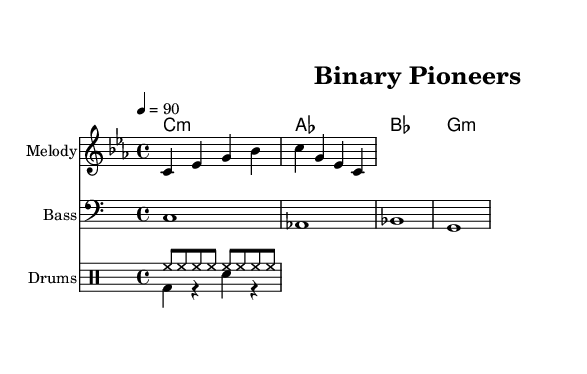What is the key signature of this music? The key signature is C minor, which is indicated by the three flat symbols located on the staff. These flats correspond to Bb, Eb, and Ab.
Answer: C minor What is the time signature of this music? The time signature shown at the beginning of the score is 4/4, which means there are four beats per measure and the quarter note gets one beat.
Answer: 4/4 What is the tempo marking for this piece? The tempo marking indicates a speed of 90 beats per minute, which is written as "4 = 90" above the musical staff. This means the quarter note is played at that speed.
Answer: 90 How many measures are in the melody? The melody contains four measures, as indicated by the grouping of notes surrounded by vertical bar lines. Count the sets of bar lines to determine the number of measures.
Answer: 4 What instruments are included in this score? The score includes a Melody staff, a Bass staff, and a Drum staff, which are labeled accordingly at the beginning of each staff. This shows that multiple musical voices are present.
Answer: Melody, Bass, Drums How many parts are there in the drum pattern? There are two parts in the drum pattern: the hi-hat pattern played in eighth notes and the combined bass and snare pattern played in quarter notes. Each is indicated by its own voice in the drum staff.
Answer: 2 What lyrical theme is suggested by the first line of the lyrics? The lyrics suggest themes of acknowledgment and tribute, particularly referencing contributions to coding and analytical engineering by early computer scientists, as indicated in the words presented.
Answer: Tribute to pioneers 